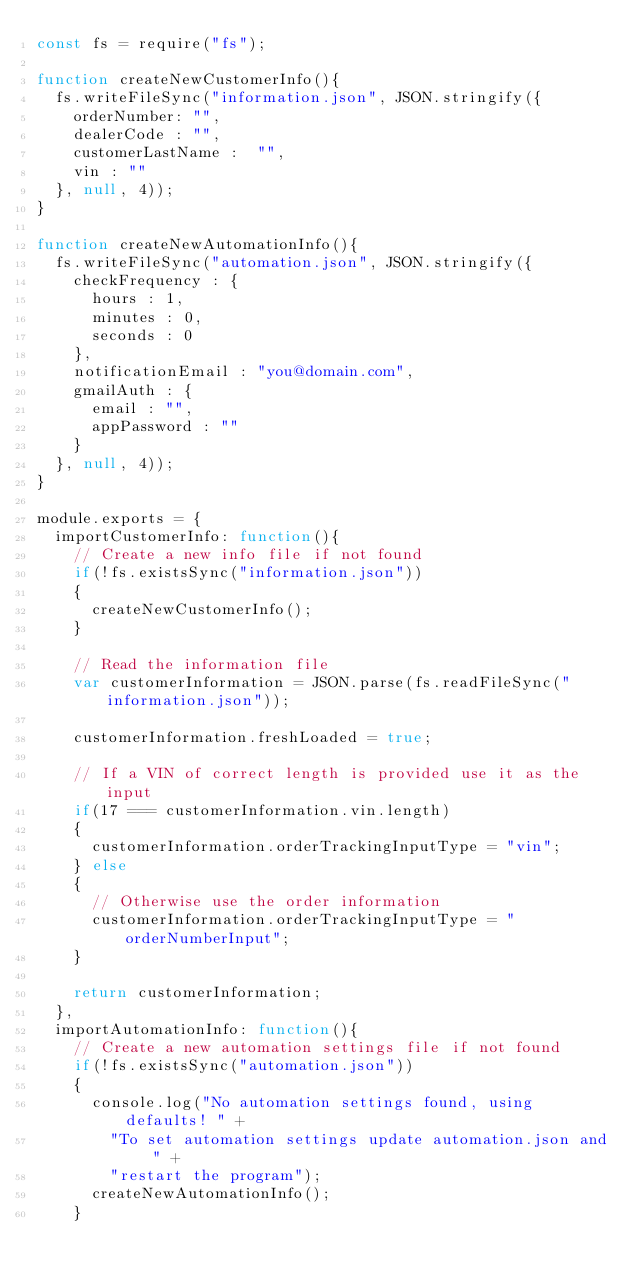<code> <loc_0><loc_0><loc_500><loc_500><_JavaScript_>const fs = require("fs");

function createNewCustomerInfo(){
	fs.writeFileSync("information.json", JSON.stringify({
		orderNumber: "",
		dealerCode : "",
		customerLastName :  "",
		vin : ""
	}, null, 4));
}

function createNewAutomationInfo(){
	fs.writeFileSync("automation.json", JSON.stringify({
		checkFrequency : {
			hours : 1,
			minutes : 0,
			seconds : 0
		},
		notificationEmail : "you@domain.com",
		gmailAuth : {
			email : "",
			appPassword : ""
		}
	}, null, 4));
}

module.exports = {
	importCustomerInfo: function(){
		// Create a new info file if not found
		if(!fs.existsSync("information.json"))
		{
			createNewCustomerInfo();
		}

		// Read the information file
		var customerInformation = JSON.parse(fs.readFileSync("information.json"));

		customerInformation.freshLoaded = true;

		// If a VIN of correct length is provided use it as the input
		if(17 === customerInformation.vin.length)
		{
			customerInformation.orderTrackingInputType = "vin";
		} else
		{
			// Otherwise use the order information
			customerInformation.orderTrackingInputType = "orderNumberInput";
		}

		return customerInformation;
	},
	importAutomationInfo: function(){
		// Create a new automation settings file if not found
		if(!fs.existsSync("automation.json"))
		{
			console.log("No automation settings found, using defaults! " +
				"To set automation settings update automation.json and " +
				"restart the program");
			createNewAutomationInfo();
		}
</code> 